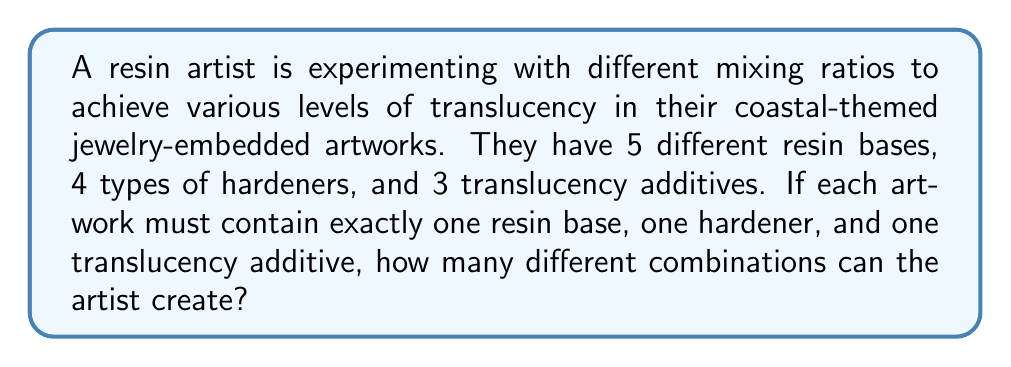Can you solve this math problem? To solve this problem, we need to use the multiplication principle of counting. This principle states that if we have a series of independent choices, the total number of ways to make these choices is the product of the number of ways to make each individual choice.

In this case, we have three independent choices:

1. Choosing a resin base (5 options)
2. Choosing a hardener (4 options)
3. Choosing a translucency additive (3 options)

For each artwork, the artist must make all three choices. The number of ways to make these choices can be calculated as follows:

$$ \text{Total combinations} = \text{(Number of resin bases)} \times \text{(Number of hardeners)} \times \text{(Number of translucency additives)} $$

$$ \text{Total combinations} = 5 \times 4 \times 3 $$

$$ \text{Total combinations} = 60 $$

Therefore, the artist can create 60 different combinations of resin mixing ratios to achieve various translucency levels in their artworks.
Answer: 60 combinations 